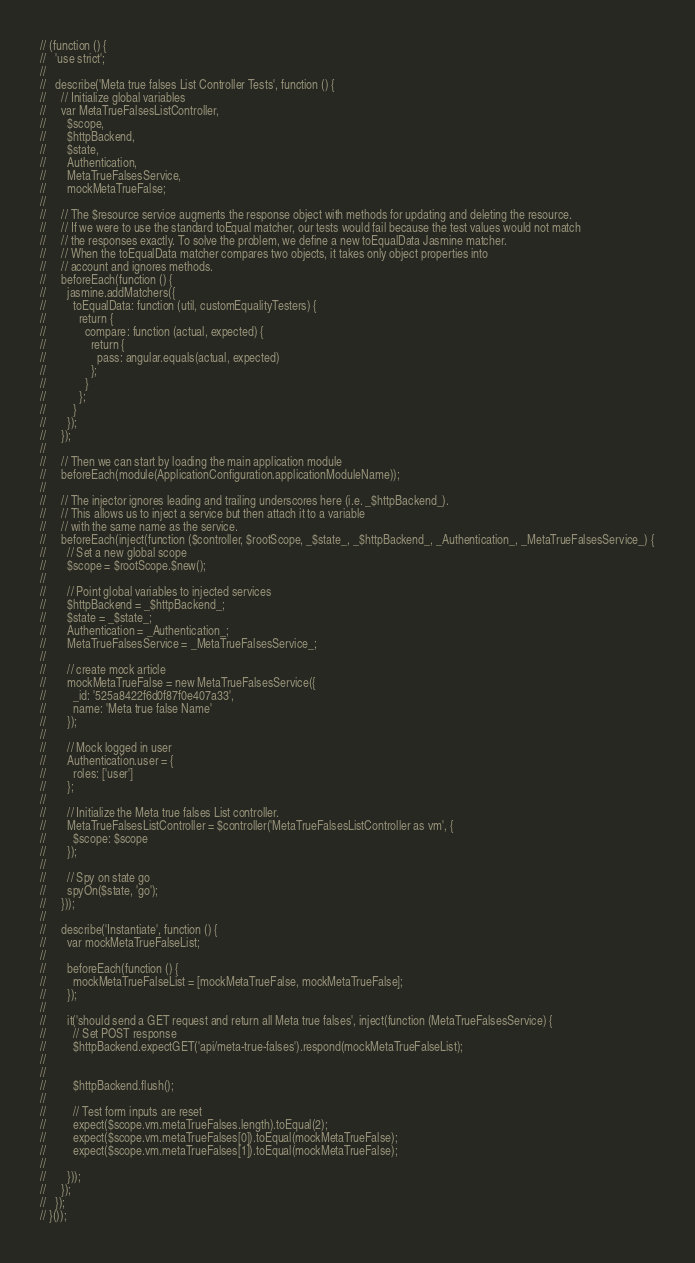Convert code to text. <code><loc_0><loc_0><loc_500><loc_500><_JavaScript_>// (function () {
//   'use strict';
//
//   describe('Meta true falses List Controller Tests', function () {
//     // Initialize global variables
//     var MetaTrueFalsesListController,
//       $scope,
//       $httpBackend,
//       $state,
//       Authentication,
//       MetaTrueFalsesService,
//       mockMetaTrueFalse;
//
//     // The $resource service augments the response object with methods for updating and deleting the resource.
//     // If we were to use the standard toEqual matcher, our tests would fail because the test values would not match
//     // the responses exactly. To solve the problem, we define a new toEqualData Jasmine matcher.
//     // When the toEqualData matcher compares two objects, it takes only object properties into
//     // account and ignores methods.
//     beforeEach(function () {
//       jasmine.addMatchers({
//         toEqualData: function (util, customEqualityTesters) {
//           return {
//             compare: function (actual, expected) {
//               return {
//                 pass: angular.equals(actual, expected)
//               };
//             }
//           };
//         }
//       });
//     });
//
//     // Then we can start by loading the main application module
//     beforeEach(module(ApplicationConfiguration.applicationModuleName));
//
//     // The injector ignores leading and trailing underscores here (i.e. _$httpBackend_).
//     // This allows us to inject a service but then attach it to a variable
//     // with the same name as the service.
//     beforeEach(inject(function ($controller, $rootScope, _$state_, _$httpBackend_, _Authentication_, _MetaTrueFalsesService_) {
//       // Set a new global scope
//       $scope = $rootScope.$new();
//
//       // Point global variables to injected services
//       $httpBackend = _$httpBackend_;
//       $state = _$state_;
//       Authentication = _Authentication_;
//       MetaTrueFalsesService = _MetaTrueFalsesService_;
//
//       // create mock article
//       mockMetaTrueFalse = new MetaTrueFalsesService({
//         _id: '525a8422f6d0f87f0e407a33',
//         name: 'Meta true false Name'
//       });
//
//       // Mock logged in user
//       Authentication.user = {
//         roles: ['user']
//       };
//
//       // Initialize the Meta true falses List controller.
//       MetaTrueFalsesListController = $controller('MetaTrueFalsesListController as vm', {
//         $scope: $scope
//       });
//
//       // Spy on state go
//       spyOn($state, 'go');
//     }));
//
//     describe('Instantiate', function () {
//       var mockMetaTrueFalseList;
//
//       beforeEach(function () {
//         mockMetaTrueFalseList = [mockMetaTrueFalse, mockMetaTrueFalse];
//       });
//
//       it('should send a GET request and return all Meta true falses', inject(function (MetaTrueFalsesService) {
//         // Set POST response
//         $httpBackend.expectGET('api/meta-true-falses').respond(mockMetaTrueFalseList);
//
//
//         $httpBackend.flush();
//
//         // Test form inputs are reset
//         expect($scope.vm.metaTrueFalses.length).toEqual(2);
//         expect($scope.vm.metaTrueFalses[0]).toEqual(mockMetaTrueFalse);
//         expect($scope.vm.metaTrueFalses[1]).toEqual(mockMetaTrueFalse);
//
//       }));
//     });
//   });
// }());
</code> 